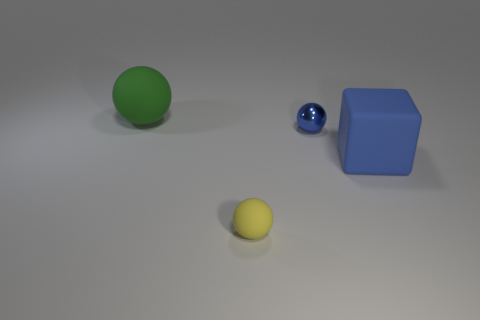What is the large green object made of? The large green object appears to be a simple geometric shape, possibly a sphere, that resembles a common rubber ball. Its surface has a matte finish commonly associated with rubber materials, which suggests its composition could indeed be rubber, though without additional context it's not possible to determine the material with certainty. 